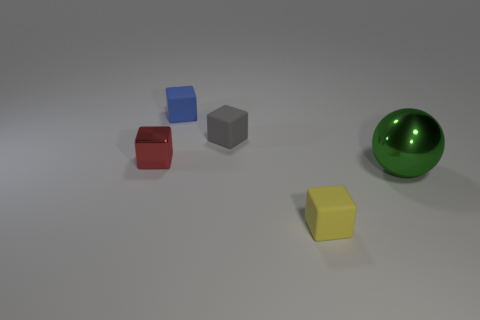Subtract all cyan blocks. Subtract all gray spheres. How many blocks are left? 4 Add 2 blue matte objects. How many objects exist? 7 Subtract all blocks. How many objects are left? 1 Subtract all purple rubber objects. Subtract all large objects. How many objects are left? 4 Add 4 small blue rubber objects. How many small blue rubber objects are left? 5 Add 5 blue blocks. How many blue blocks exist? 6 Subtract 0 green cylinders. How many objects are left? 5 